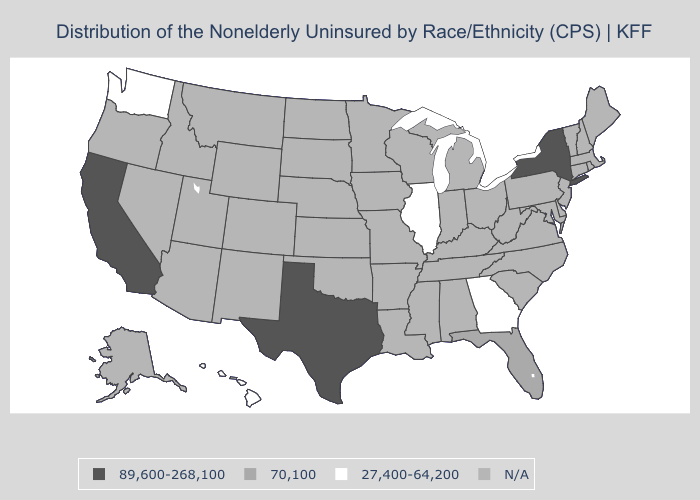Name the states that have a value in the range 89,600-268,100?
Answer briefly. California, New York, Texas. Which states have the lowest value in the USA?
Be succinct. Georgia, Hawaii, Illinois, Washington. What is the value of Kentucky?
Give a very brief answer. N/A. Name the states that have a value in the range 89,600-268,100?
Quick response, please. California, New York, Texas. What is the highest value in states that border Oregon?
Give a very brief answer. 89,600-268,100. Which states have the lowest value in the Northeast?
Quick response, please. New York. What is the value of South Dakota?
Keep it brief. N/A. What is the value of Kansas?
Answer briefly. N/A. Name the states that have a value in the range 70,100?
Answer briefly. Florida. What is the value of New Jersey?
Quick response, please. N/A. How many symbols are there in the legend?
Answer briefly. 4. Does Texas have the lowest value in the South?
Keep it brief. No. 